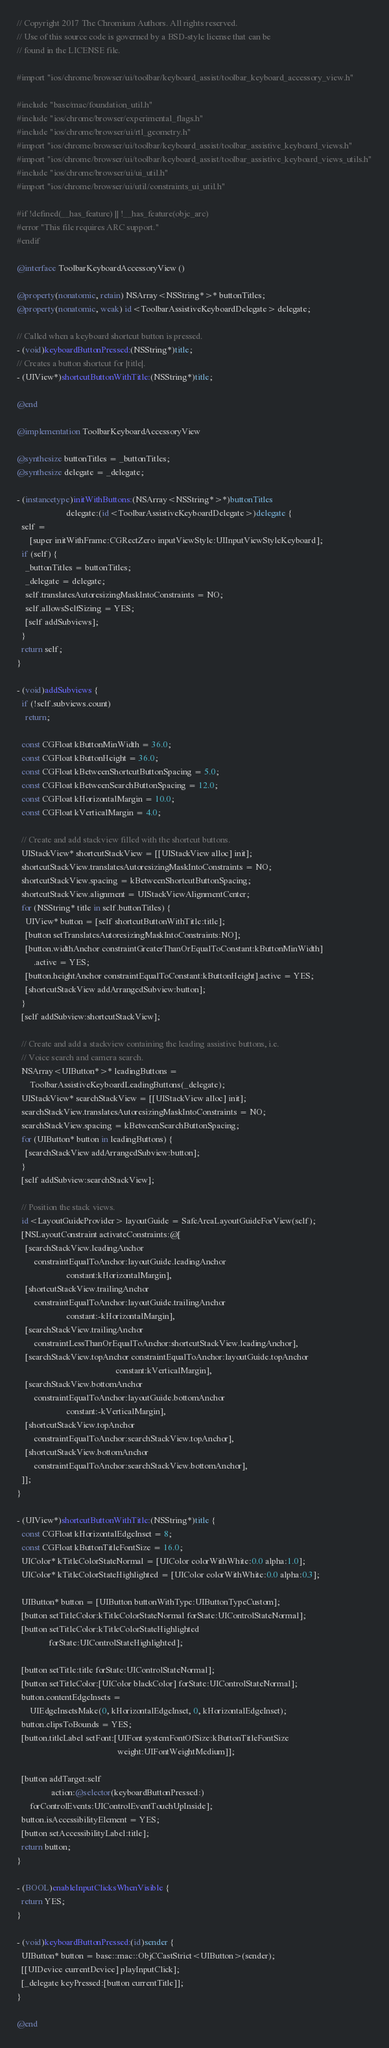Convert code to text. <code><loc_0><loc_0><loc_500><loc_500><_ObjectiveC_>// Copyright 2017 The Chromium Authors. All rights reserved.
// Use of this source code is governed by a BSD-style license that can be
// found in the LICENSE file.

#import "ios/chrome/browser/ui/toolbar/keyboard_assist/toolbar_keyboard_accessory_view.h"

#include "base/mac/foundation_util.h"
#include "ios/chrome/browser/experimental_flags.h"
#include "ios/chrome/browser/ui/rtl_geometry.h"
#import "ios/chrome/browser/ui/toolbar/keyboard_assist/toolbar_assistive_keyboard_views.h"
#import "ios/chrome/browser/ui/toolbar/keyboard_assist/toolbar_assistive_keyboard_views_utils.h"
#include "ios/chrome/browser/ui/ui_util.h"
#import "ios/chrome/browser/ui/util/constraints_ui_util.h"

#if !defined(__has_feature) || !__has_feature(objc_arc)
#error "This file requires ARC support."
#endif

@interface ToolbarKeyboardAccessoryView ()

@property(nonatomic, retain) NSArray<NSString*>* buttonTitles;
@property(nonatomic, weak) id<ToolbarAssistiveKeyboardDelegate> delegate;

// Called when a keyboard shortcut button is pressed.
- (void)keyboardButtonPressed:(NSString*)title;
// Creates a button shortcut for |title|.
- (UIView*)shortcutButtonWithTitle:(NSString*)title;

@end

@implementation ToolbarKeyboardAccessoryView

@synthesize buttonTitles = _buttonTitles;
@synthesize delegate = _delegate;

- (instancetype)initWithButtons:(NSArray<NSString*>*)buttonTitles
                       delegate:(id<ToolbarAssistiveKeyboardDelegate>)delegate {
  self =
      [super initWithFrame:CGRectZero inputViewStyle:UIInputViewStyleKeyboard];
  if (self) {
    _buttonTitles = buttonTitles;
    _delegate = delegate;
    self.translatesAutoresizingMaskIntoConstraints = NO;
    self.allowsSelfSizing = YES;
    [self addSubviews];
  }
  return self;
}

- (void)addSubviews {
  if (!self.subviews.count)
    return;

  const CGFloat kButtonMinWidth = 36.0;
  const CGFloat kButtonHeight = 36.0;
  const CGFloat kBetweenShortcutButtonSpacing = 5.0;
  const CGFloat kBetweenSearchButtonSpacing = 12.0;
  const CGFloat kHorizontalMargin = 10.0;
  const CGFloat kVerticalMargin = 4.0;

  // Create and add stackview filled with the shortcut buttons.
  UIStackView* shortcutStackView = [[UIStackView alloc] init];
  shortcutStackView.translatesAutoresizingMaskIntoConstraints = NO;
  shortcutStackView.spacing = kBetweenShortcutButtonSpacing;
  shortcutStackView.alignment = UIStackViewAlignmentCenter;
  for (NSString* title in self.buttonTitles) {
    UIView* button = [self shortcutButtonWithTitle:title];
    [button setTranslatesAutoresizingMaskIntoConstraints:NO];
    [button.widthAnchor constraintGreaterThanOrEqualToConstant:kButtonMinWidth]
        .active = YES;
    [button.heightAnchor constraintEqualToConstant:kButtonHeight].active = YES;
    [shortcutStackView addArrangedSubview:button];
  }
  [self addSubview:shortcutStackView];

  // Create and add a stackview containing the leading assistive buttons, i.e.
  // Voice search and camera search.
  NSArray<UIButton*>* leadingButtons =
      ToolbarAssistiveKeyboardLeadingButtons(_delegate);
  UIStackView* searchStackView = [[UIStackView alloc] init];
  searchStackView.translatesAutoresizingMaskIntoConstraints = NO;
  searchStackView.spacing = kBetweenSearchButtonSpacing;
  for (UIButton* button in leadingButtons) {
    [searchStackView addArrangedSubview:button];
  }
  [self addSubview:searchStackView];

  // Position the stack views.
  id<LayoutGuideProvider> layoutGuide = SafeAreaLayoutGuideForView(self);
  [NSLayoutConstraint activateConstraints:@[
    [searchStackView.leadingAnchor
        constraintEqualToAnchor:layoutGuide.leadingAnchor
                       constant:kHorizontalMargin],
    [shortcutStackView.trailingAnchor
        constraintEqualToAnchor:layoutGuide.trailingAnchor
                       constant:-kHorizontalMargin],
    [searchStackView.trailingAnchor
        constraintLessThanOrEqualToAnchor:shortcutStackView.leadingAnchor],
    [searchStackView.topAnchor constraintEqualToAnchor:layoutGuide.topAnchor
                                              constant:kVerticalMargin],
    [searchStackView.bottomAnchor
        constraintEqualToAnchor:layoutGuide.bottomAnchor
                       constant:-kVerticalMargin],
    [shortcutStackView.topAnchor
        constraintEqualToAnchor:searchStackView.topAnchor],
    [shortcutStackView.bottomAnchor
        constraintEqualToAnchor:searchStackView.bottomAnchor],
  ]];
}

- (UIView*)shortcutButtonWithTitle:(NSString*)title {
  const CGFloat kHorizontalEdgeInset = 8;
  const CGFloat kButtonTitleFontSize = 16.0;
  UIColor* kTitleColorStateNormal = [UIColor colorWithWhite:0.0 alpha:1.0];
  UIColor* kTitleColorStateHighlighted = [UIColor colorWithWhite:0.0 alpha:0.3];

  UIButton* button = [UIButton buttonWithType:UIButtonTypeCustom];
  [button setTitleColor:kTitleColorStateNormal forState:UIControlStateNormal];
  [button setTitleColor:kTitleColorStateHighlighted
               forState:UIControlStateHighlighted];

  [button setTitle:title forState:UIControlStateNormal];
  [button setTitleColor:[UIColor blackColor] forState:UIControlStateNormal];
  button.contentEdgeInsets =
      UIEdgeInsetsMake(0, kHorizontalEdgeInset, 0, kHorizontalEdgeInset);
  button.clipsToBounds = YES;
  [button.titleLabel setFont:[UIFont systemFontOfSize:kButtonTitleFontSize
                                               weight:UIFontWeightMedium]];

  [button addTarget:self
                action:@selector(keyboardButtonPressed:)
      forControlEvents:UIControlEventTouchUpInside];
  button.isAccessibilityElement = YES;
  [button setAccessibilityLabel:title];
  return button;
}

- (BOOL)enableInputClicksWhenVisible {
  return YES;
}

- (void)keyboardButtonPressed:(id)sender {
  UIButton* button = base::mac::ObjCCastStrict<UIButton>(sender);
  [[UIDevice currentDevice] playInputClick];
  [_delegate keyPressed:[button currentTitle]];
}

@end
</code> 